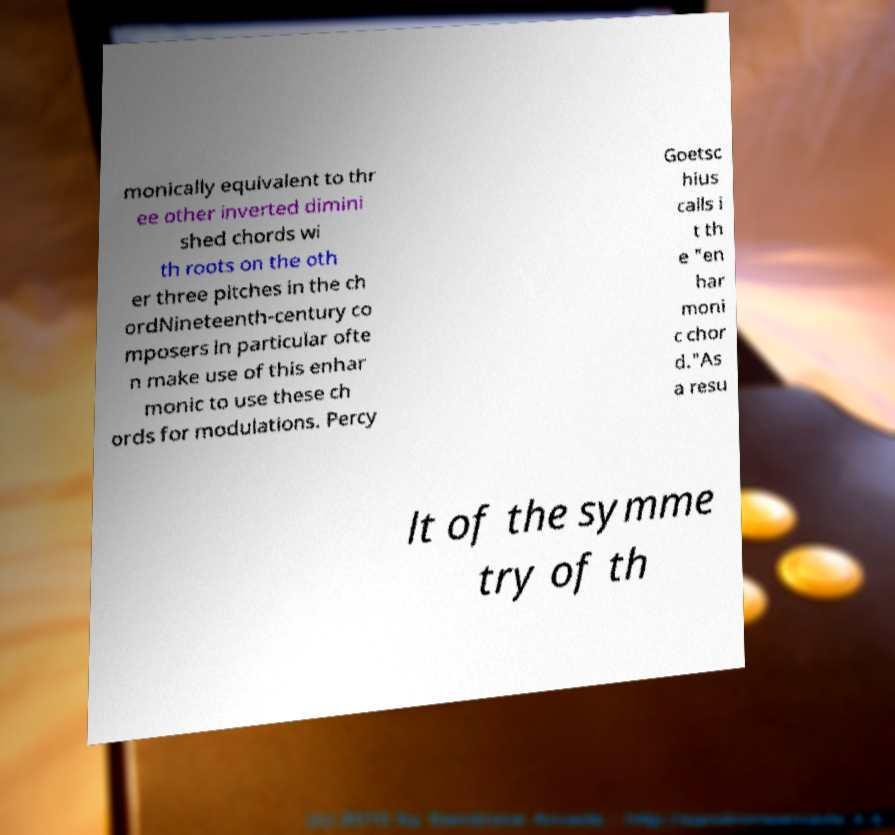What messages or text are displayed in this image? I need them in a readable, typed format. monically equivalent to thr ee other inverted dimini shed chords wi th roots on the oth er three pitches in the ch ordNineteenth-century co mposers in particular ofte n make use of this enhar monic to use these ch ords for modulations. Percy Goetsc hius calls i t th e "en har moni c chor d."As a resu lt of the symme try of th 